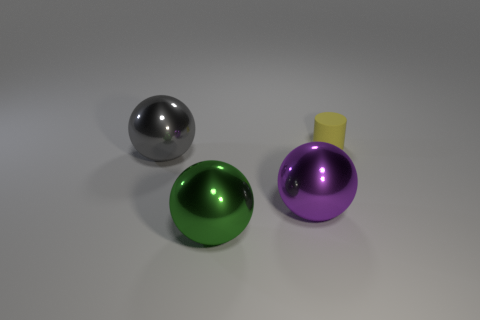How does the lighting affect the visual appearance of the metallic objects? The directional lighting creates a high contrast on the metallic objects, resulting in bright highlights and deep shadows which emphasize their shiny, reflective surfaces. 